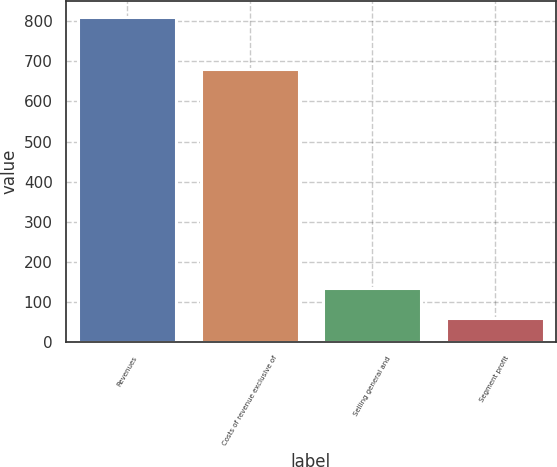<chart> <loc_0><loc_0><loc_500><loc_500><bar_chart><fcel>Revenues<fcel>Costs of revenue exclusive of<fcel>Selling general and<fcel>Segment profit<nl><fcel>810<fcel>682<fcel>134.1<fcel>59<nl></chart> 